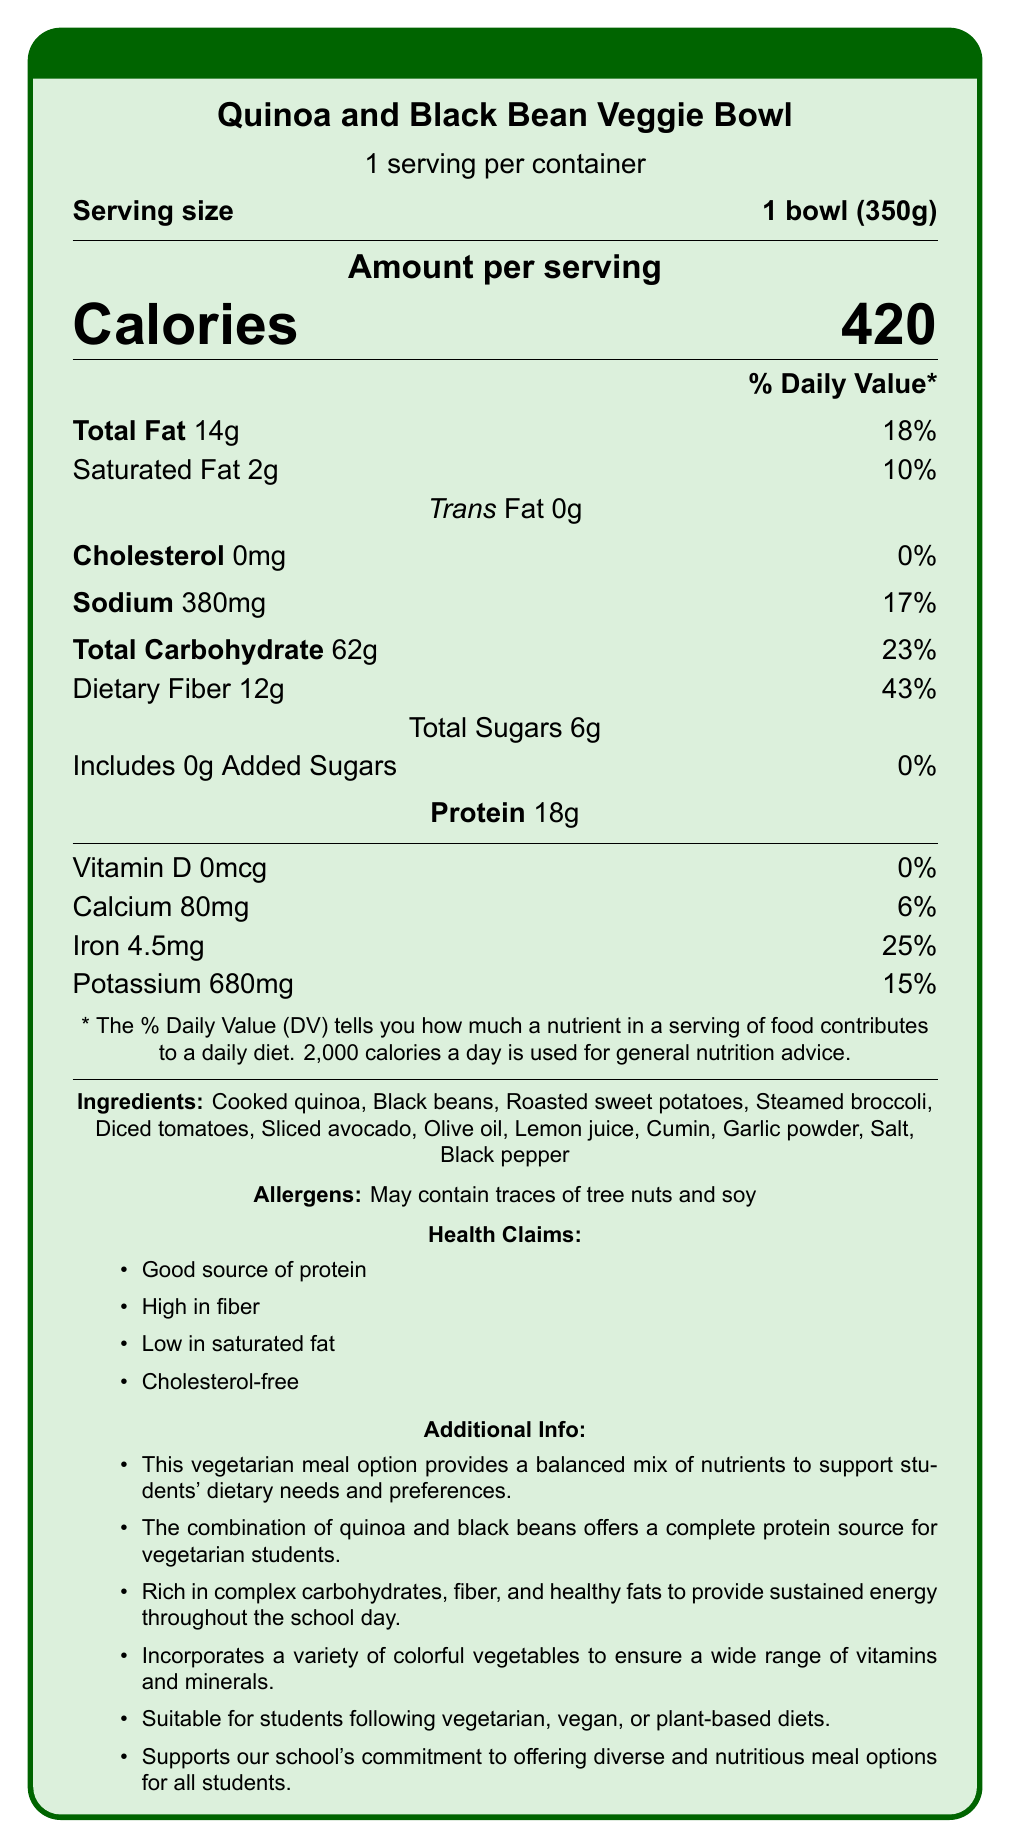What is the serving size of the Quinoa and Black Bean Veggie Bowl? The document states the serving size as 1 bowl (350g).
Answer: 1 bowl (350g) How many calories are in one serving of the Quinoa and Black Bean Veggie Bowl? The document lists 420 calories for one serving.
Answer: 420 calories Which ingredient in the Quinoa and Black Bean Veggie Bowl could potentially cause an allergic reaction? The allergens section mentions that the meal may contain traces of tree nuts and soy.
Answer: Tree nuts and soy What percentage of the daily value of dietary fiber does one serving of the Quinoa and Black Bean Veggie Bowl provide? The document shows that one serving provides 43% of the daily value for dietary fiber.
Answer: 43% Name two nutrients that the Quinoa and Black Bean Veggie Bowl is a good source of. The health claims list "Good source of protein" and "High in fiber".
Answer: Protein and fiber Does the Quinoa and Black Bean Veggie Bowl contain any added sugars? The added sugars section shows "0g," indicating there are no added sugars.
Answer: No What is the total carbohydrate content in one serving of the Quinoa and Black Bean Veggie Bowl? A. 14g B. 62g C. 38g D. 6g The total carbohydrate content is listed as 62g.
Answer: B Which of the following health claims is true for the Quinoa and Black Bean Veggie Bowl? A. High in saturated fat B. Cholesterol-free C. Low in protein D. Contains added sugars The document states that the meal is cholesterol-free among its health claims.
Answer: B This vegetarian meal option provides a balanced mix of nutrients to support students' dietary needs and preferences. The additional info section mentions this explicitly.
Answer: Yes Summarize the main idea of the document. The document includes detailed information about the nutritional value, ingredients, potential allergens, and health benefits of the meal option, highlighting its suitability for various dietary needs and its role in promoting balanced nutrition.
Answer: The document presents the nutrition facts, ingredients, allergens, health claims, and additional information about the Quinoa and Black Bean Veggie Bowl, a vegetarian meal option designed to support diverse dietary preferences and provide balanced nutrition. How many vitamins and minerals are listed in the document? The vitamins and minerals listed are Vitamin D, Calcium, Iron, and Potassium.
Answer: 4 What is the primary source of protein in this vegetarian meal? While the document mentions a good source of protein, it does not specify the primary source among the ingredients explicitly.
Answer: Cannot be determined 